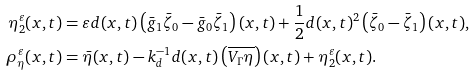<formula> <loc_0><loc_0><loc_500><loc_500>\eta _ { 2 } ^ { \varepsilon } ( x , t ) & = \varepsilon d ( x , t ) \left ( \bar { g } _ { 1 } \bar { \zeta } _ { 0 } - \bar { g } _ { 0 } \bar { \zeta } _ { 1 } \right ) ( x , t ) + \frac { 1 } { 2 } d ( x , t ) ^ { 2 } \left ( \bar { \zeta } _ { 0 } - \bar { \zeta } _ { 1 } \right ) ( x , t ) , \\ \rho _ { \eta } ^ { \varepsilon } ( x , t ) & = \bar { \eta } ( x , t ) - k _ { d } ^ { - 1 } d ( x , t ) \left ( \overline { V _ { \Gamma } \eta } \right ) ( x , t ) + \eta _ { 2 } ^ { \varepsilon } ( x , t ) .</formula> 